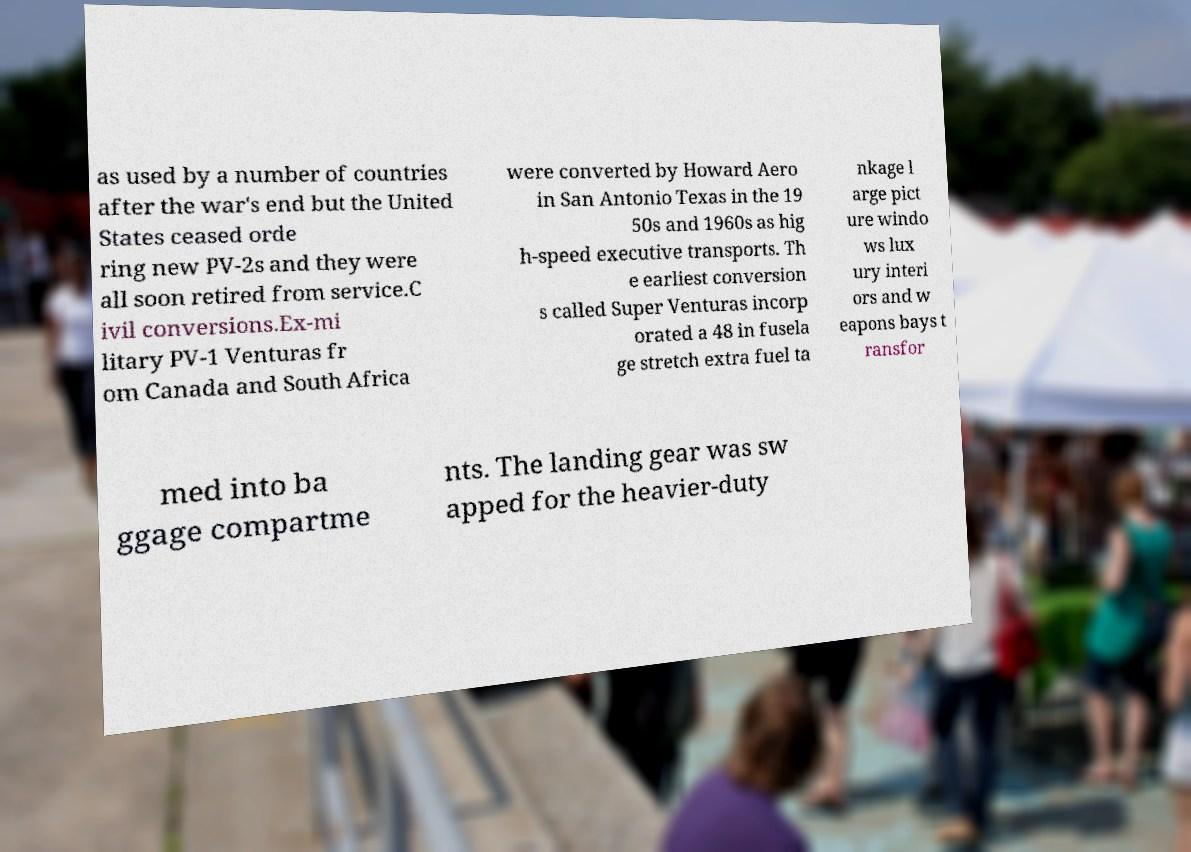Could you extract and type out the text from this image? as used by a number of countries after the war's end but the United States ceased orde ring new PV-2s and they were all soon retired from service.C ivil conversions.Ex-mi litary PV-1 Venturas fr om Canada and South Africa were converted by Howard Aero in San Antonio Texas in the 19 50s and 1960s as hig h-speed executive transports. Th e earliest conversion s called Super Venturas incorp orated a 48 in fusela ge stretch extra fuel ta nkage l arge pict ure windo ws lux ury interi ors and w eapons bays t ransfor med into ba ggage compartme nts. The landing gear was sw apped for the heavier-duty 